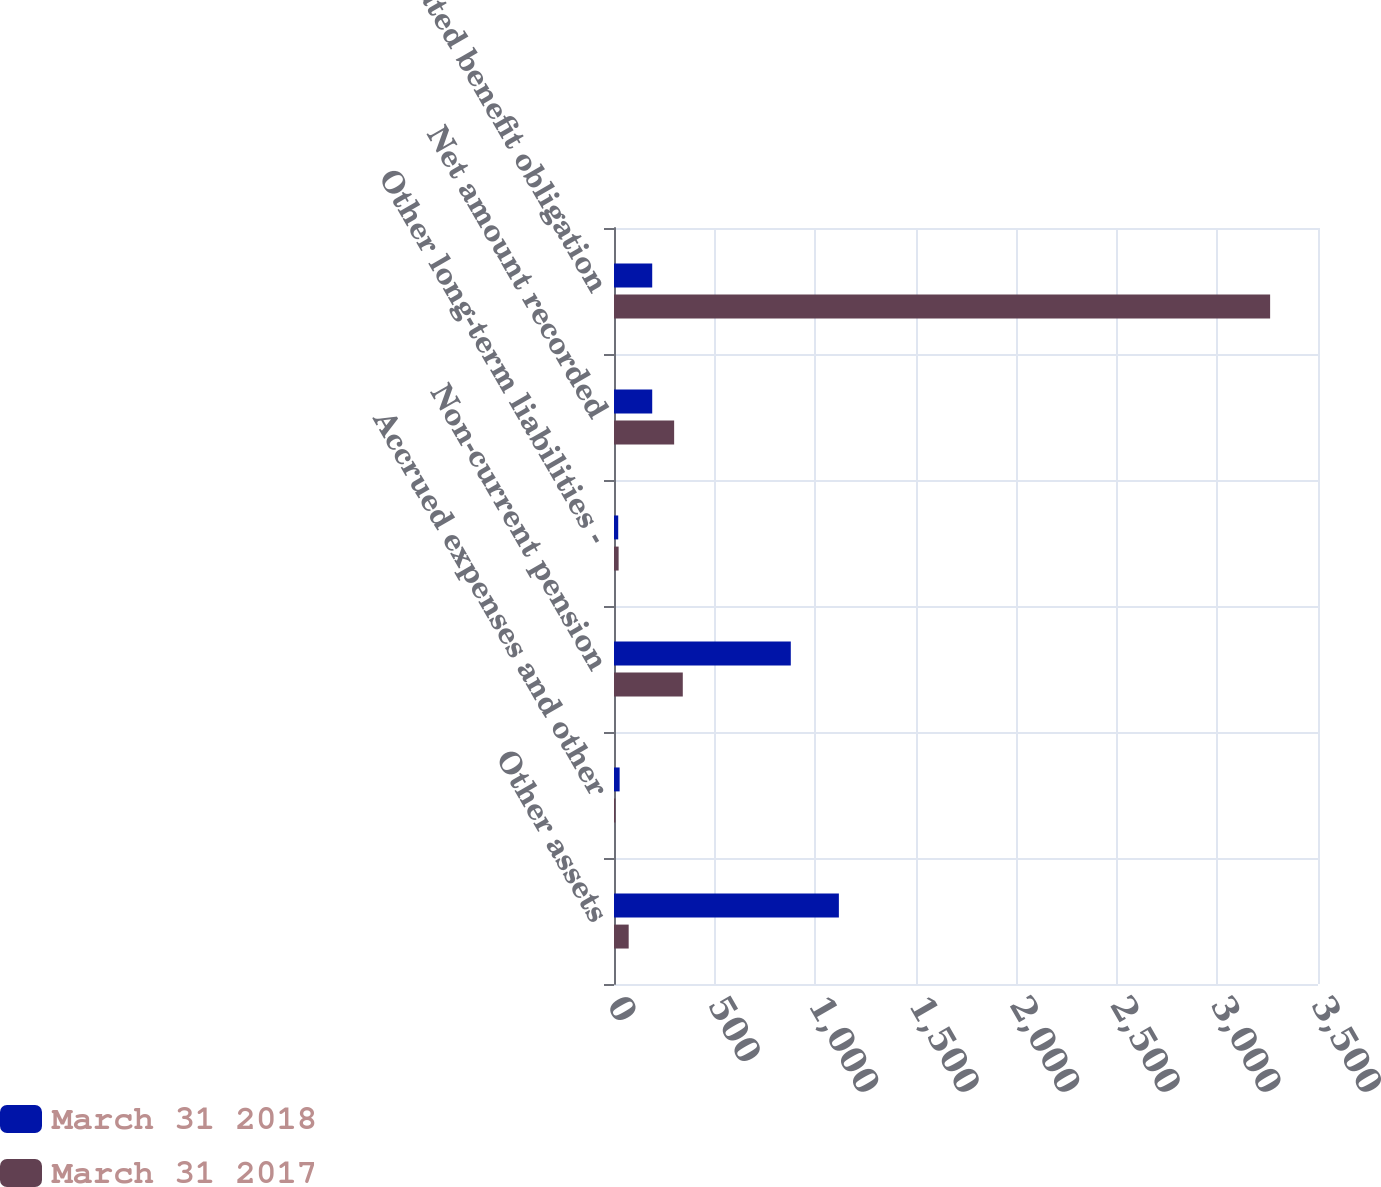Convert chart. <chart><loc_0><loc_0><loc_500><loc_500><stacked_bar_chart><ecel><fcel>Other assets<fcel>Accrued expenses and other<fcel>Non-current pension<fcel>Other long-term liabilities -<fcel>Net amount recorded<fcel>Accumulated benefit obligation<nl><fcel>March 31 2018<fcel>1118<fcel>28<fcel>879<fcel>21<fcel>190<fcel>190<nl><fcel>March 31 2017<fcel>73<fcel>7<fcel>342<fcel>23<fcel>299<fcel>3262<nl></chart> 